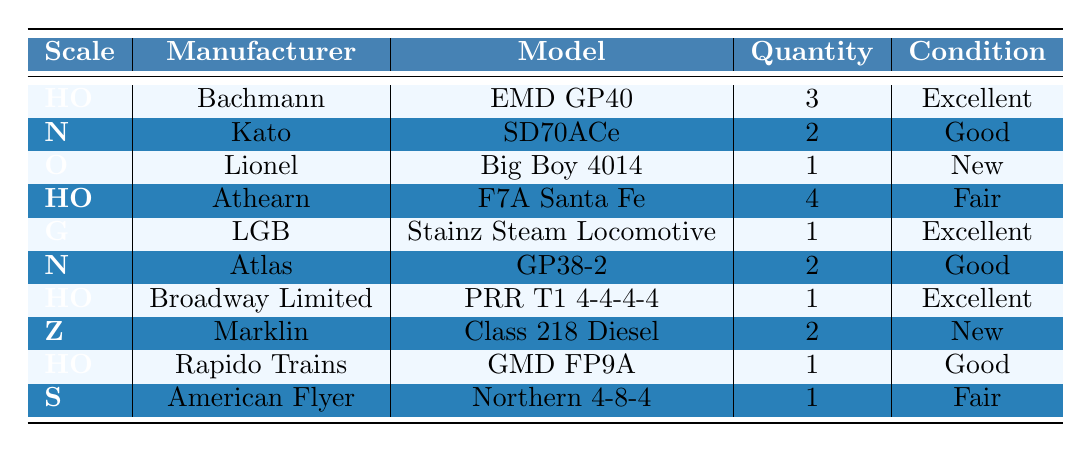What scale has the highest quantity of locomotives? By reviewing the table, the HO scale has a quantity of 4 for the Athearn model and 3 for the Bachmann model, totaling 7. Other scales have lower quantities.
Answer: HO How many manufacturers are listed for the N scale locomotives? There are two manufacturers listed for the N scale: Kato and Atlas.
Answer: 2 Is there a locomotive in the inventory that is in "New" condition? The table indicates that there is one locomotive, the Big Boy 4014 by Lionel in the O scale, which is classified as "New."
Answer: Yes What is the total quantity of HO scale locomotives? The total for HO scale locomotives is calculated by adding the quantities: 3 (Bachmann) + 4 (Athearn) + 1 (Broadway Limited) + 1 (Rapido Trains) = 9.
Answer: 9 Which manufacturer has a "Fair" condition locomotive in the S scale? The only manufacturer listed for the S scale is American Flyer, which has the Northern 4-8-4 listed as "Fair."
Answer: American Flyer How many locomotives are in excellent condition? Adding the excellent condition locomotives gives: 3 (Bachmann) + 1 (LGB) + 1 (Broadway Limited) = 5 in excellent condition.
Answer: 5 What scale has the least quantity of locomotives? The G scale and O scale each have one locomotive listed. Thus, they both share the least quantity.
Answer: G and O Which model has the lowest condition rating among all listed? The lowest condition rating in the inventory is "Fair," which applies to the Athearn's F7A Santa Fe, the S scale's Northern 4-8-4, and is less than any other model's condition.
Answer: Fair What is the total number of locomotives listed in the inventory? By adding all the quantities together: 3 + 2 + 1 + 4 + 1 + 2 + 1 + 2 + 1 + 1 = 18 locomotives in total.
Answer: 18 Is there more than one model from the same manufacturer in the table? Looking at the table, none of the manufacturers repeat for different models—they all have unique models listed.
Answer: No 